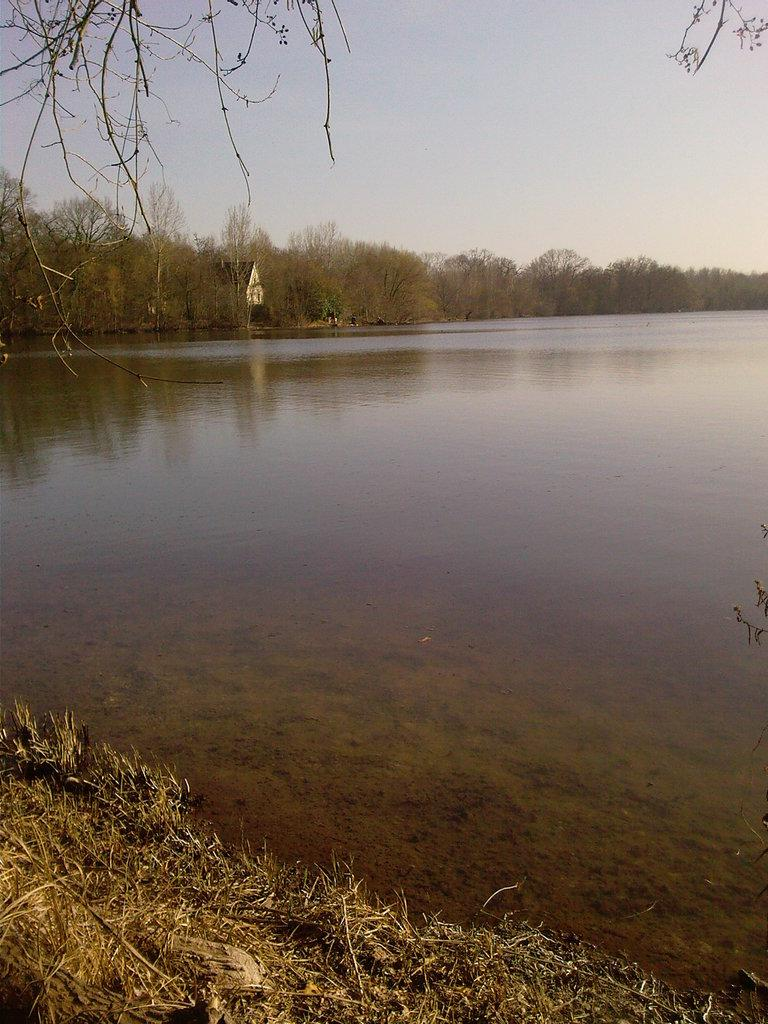What type of vegetation is present in the image? There is grass in the image. What else can be seen in the image besides grass? There is water in the image. What can be seen in the background of the image? There are trees in the background of the image. What type of dime is visible on the canvas in the image? There is no dime or canvas present in the image; it features grass, water, and trees. What type of trousers are the trees wearing in the image? Trees do not wear trousers, so this question cannot be answered. 